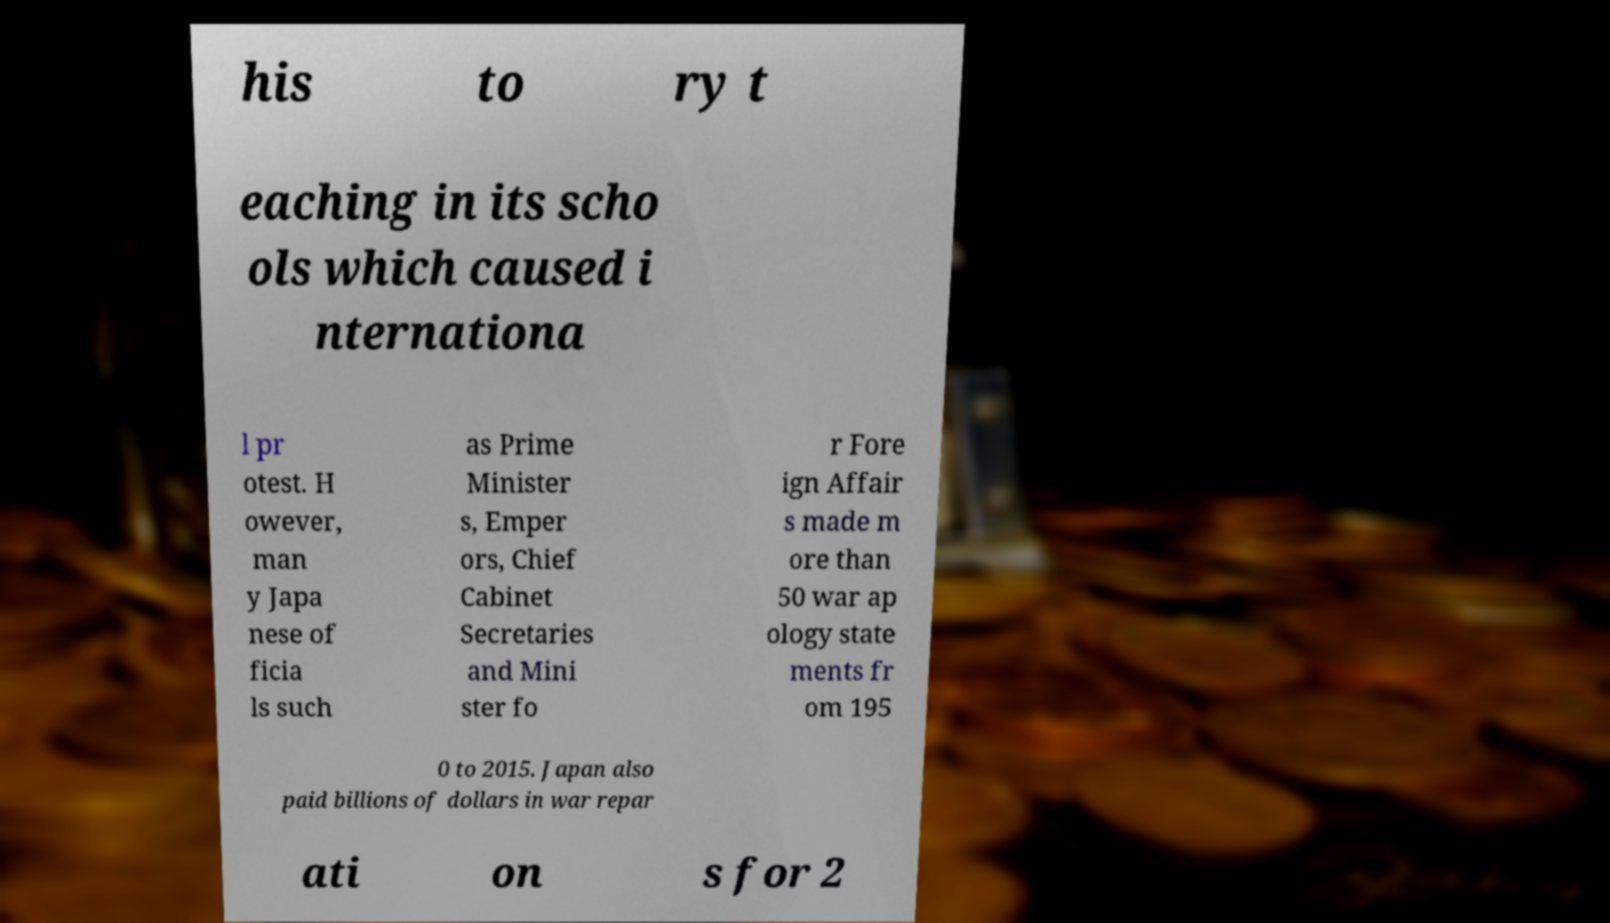What messages or text are displayed in this image? I need them in a readable, typed format. his to ry t eaching in its scho ols which caused i nternationa l pr otest. H owever, man y Japa nese of ficia ls such as Prime Minister s, Emper ors, Chief Cabinet Secretaries and Mini ster fo r Fore ign Affair s made m ore than 50 war ap ology state ments fr om 195 0 to 2015. Japan also paid billions of dollars in war repar ati on s for 2 